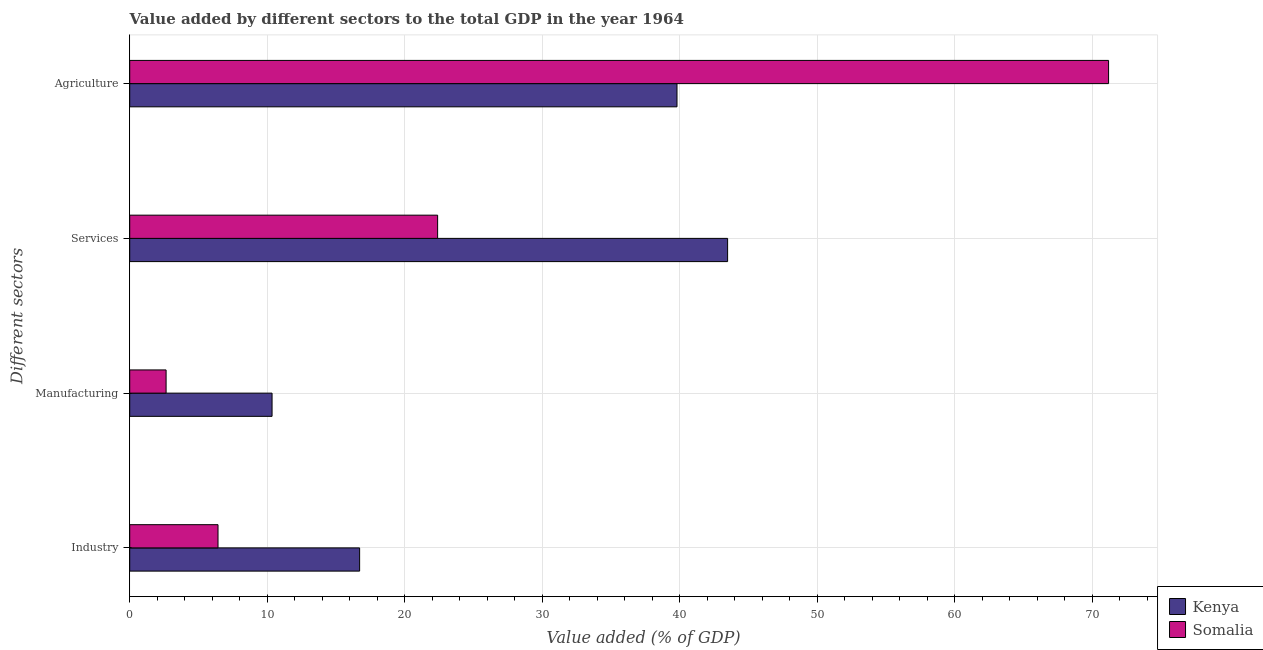How many different coloured bars are there?
Give a very brief answer. 2. How many groups of bars are there?
Keep it short and to the point. 4. Are the number of bars on each tick of the Y-axis equal?
Ensure brevity in your answer.  Yes. How many bars are there on the 1st tick from the top?
Offer a terse response. 2. What is the label of the 2nd group of bars from the top?
Give a very brief answer. Services. What is the value added by manufacturing sector in Kenya?
Make the answer very short. 10.35. Across all countries, what is the maximum value added by manufacturing sector?
Ensure brevity in your answer.  10.35. Across all countries, what is the minimum value added by industrial sector?
Ensure brevity in your answer.  6.42. In which country was the value added by agricultural sector maximum?
Provide a short and direct response. Somalia. In which country was the value added by manufacturing sector minimum?
Offer a terse response. Somalia. What is the total value added by agricultural sector in the graph?
Ensure brevity in your answer.  110.99. What is the difference between the value added by manufacturing sector in Kenya and that in Somalia?
Provide a short and direct response. 7.71. What is the difference between the value added by industrial sector in Somalia and the value added by agricultural sector in Kenya?
Your response must be concise. -33.38. What is the average value added by industrial sector per country?
Give a very brief answer. 11.57. What is the difference between the value added by services sector and value added by industrial sector in Somalia?
Give a very brief answer. 15.97. In how many countries, is the value added by manufacturing sector greater than 36 %?
Your answer should be compact. 0. What is the ratio of the value added by industrial sector in Kenya to that in Somalia?
Offer a terse response. 2.6. Is the difference between the value added by agricultural sector in Kenya and Somalia greater than the difference between the value added by industrial sector in Kenya and Somalia?
Provide a short and direct response. No. What is the difference between the highest and the second highest value added by industrial sector?
Keep it short and to the point. 10.3. What is the difference between the highest and the lowest value added by manufacturing sector?
Your answer should be compact. 7.71. In how many countries, is the value added by services sector greater than the average value added by services sector taken over all countries?
Provide a succinct answer. 1. Is the sum of the value added by industrial sector in Kenya and Somalia greater than the maximum value added by agricultural sector across all countries?
Your answer should be compact. No. Is it the case that in every country, the sum of the value added by manufacturing sector and value added by agricultural sector is greater than the sum of value added by services sector and value added by industrial sector?
Your answer should be compact. Yes. What does the 2nd bar from the top in Manufacturing represents?
Ensure brevity in your answer.  Kenya. What does the 2nd bar from the bottom in Industry represents?
Provide a short and direct response. Somalia. Is it the case that in every country, the sum of the value added by industrial sector and value added by manufacturing sector is greater than the value added by services sector?
Provide a short and direct response. No. Are all the bars in the graph horizontal?
Give a very brief answer. Yes. What is the difference between two consecutive major ticks on the X-axis?
Ensure brevity in your answer.  10. Are the values on the major ticks of X-axis written in scientific E-notation?
Offer a very short reply. No. How are the legend labels stacked?
Ensure brevity in your answer.  Vertical. What is the title of the graph?
Keep it short and to the point. Value added by different sectors to the total GDP in the year 1964. What is the label or title of the X-axis?
Keep it short and to the point. Value added (% of GDP). What is the label or title of the Y-axis?
Give a very brief answer. Different sectors. What is the Value added (% of GDP) of Kenya in Industry?
Ensure brevity in your answer.  16.72. What is the Value added (% of GDP) in Somalia in Industry?
Offer a terse response. 6.42. What is the Value added (% of GDP) of Kenya in Manufacturing?
Your answer should be compact. 10.35. What is the Value added (% of GDP) in Somalia in Manufacturing?
Your response must be concise. 2.65. What is the Value added (% of GDP) of Kenya in Services?
Make the answer very short. 43.48. What is the Value added (% of GDP) of Somalia in Services?
Your answer should be very brief. 22.39. What is the Value added (% of GDP) of Kenya in Agriculture?
Offer a terse response. 39.8. What is the Value added (% of GDP) of Somalia in Agriculture?
Give a very brief answer. 71.19. Across all Different sectors, what is the maximum Value added (% of GDP) of Kenya?
Provide a short and direct response. 43.48. Across all Different sectors, what is the maximum Value added (% of GDP) of Somalia?
Provide a succinct answer. 71.19. Across all Different sectors, what is the minimum Value added (% of GDP) in Kenya?
Keep it short and to the point. 10.35. Across all Different sectors, what is the minimum Value added (% of GDP) of Somalia?
Offer a very short reply. 2.65. What is the total Value added (% of GDP) of Kenya in the graph?
Provide a succinct answer. 110.35. What is the total Value added (% of GDP) in Somalia in the graph?
Your answer should be compact. 102.64. What is the difference between the Value added (% of GDP) in Kenya in Industry and that in Manufacturing?
Provide a short and direct response. 6.37. What is the difference between the Value added (% of GDP) of Somalia in Industry and that in Manufacturing?
Your answer should be compact. 3.78. What is the difference between the Value added (% of GDP) of Kenya in Industry and that in Services?
Offer a very short reply. -26.76. What is the difference between the Value added (% of GDP) in Somalia in Industry and that in Services?
Provide a short and direct response. -15.97. What is the difference between the Value added (% of GDP) of Kenya in Industry and that in Agriculture?
Provide a short and direct response. -23.08. What is the difference between the Value added (% of GDP) of Somalia in Industry and that in Agriculture?
Your answer should be very brief. -64.77. What is the difference between the Value added (% of GDP) of Kenya in Manufacturing and that in Services?
Keep it short and to the point. -33.13. What is the difference between the Value added (% of GDP) of Somalia in Manufacturing and that in Services?
Provide a succinct answer. -19.75. What is the difference between the Value added (% of GDP) in Kenya in Manufacturing and that in Agriculture?
Offer a terse response. -29.45. What is the difference between the Value added (% of GDP) in Somalia in Manufacturing and that in Agriculture?
Ensure brevity in your answer.  -68.54. What is the difference between the Value added (% of GDP) in Kenya in Services and that in Agriculture?
Offer a terse response. 3.68. What is the difference between the Value added (% of GDP) of Somalia in Services and that in Agriculture?
Make the answer very short. -48.8. What is the difference between the Value added (% of GDP) of Kenya in Industry and the Value added (% of GDP) of Somalia in Manufacturing?
Give a very brief answer. 14.07. What is the difference between the Value added (% of GDP) of Kenya in Industry and the Value added (% of GDP) of Somalia in Services?
Provide a succinct answer. -5.67. What is the difference between the Value added (% of GDP) of Kenya in Industry and the Value added (% of GDP) of Somalia in Agriculture?
Offer a terse response. -54.47. What is the difference between the Value added (% of GDP) in Kenya in Manufacturing and the Value added (% of GDP) in Somalia in Services?
Your answer should be very brief. -12.04. What is the difference between the Value added (% of GDP) of Kenya in Manufacturing and the Value added (% of GDP) of Somalia in Agriculture?
Ensure brevity in your answer.  -60.84. What is the difference between the Value added (% of GDP) in Kenya in Services and the Value added (% of GDP) in Somalia in Agriculture?
Provide a succinct answer. -27.71. What is the average Value added (% of GDP) of Kenya per Different sectors?
Make the answer very short. 27.59. What is the average Value added (% of GDP) in Somalia per Different sectors?
Ensure brevity in your answer.  25.66. What is the difference between the Value added (% of GDP) of Kenya and Value added (% of GDP) of Somalia in Industry?
Ensure brevity in your answer.  10.3. What is the difference between the Value added (% of GDP) of Kenya and Value added (% of GDP) of Somalia in Manufacturing?
Provide a short and direct response. 7.71. What is the difference between the Value added (% of GDP) of Kenya and Value added (% of GDP) of Somalia in Services?
Offer a very short reply. 21.09. What is the difference between the Value added (% of GDP) of Kenya and Value added (% of GDP) of Somalia in Agriculture?
Provide a short and direct response. -31.39. What is the ratio of the Value added (% of GDP) of Kenya in Industry to that in Manufacturing?
Your answer should be very brief. 1.62. What is the ratio of the Value added (% of GDP) in Somalia in Industry to that in Manufacturing?
Your answer should be compact. 2.43. What is the ratio of the Value added (% of GDP) of Kenya in Industry to that in Services?
Give a very brief answer. 0.38. What is the ratio of the Value added (% of GDP) in Somalia in Industry to that in Services?
Offer a very short reply. 0.29. What is the ratio of the Value added (% of GDP) in Kenya in Industry to that in Agriculture?
Give a very brief answer. 0.42. What is the ratio of the Value added (% of GDP) of Somalia in Industry to that in Agriculture?
Offer a very short reply. 0.09. What is the ratio of the Value added (% of GDP) of Kenya in Manufacturing to that in Services?
Provide a succinct answer. 0.24. What is the ratio of the Value added (% of GDP) of Somalia in Manufacturing to that in Services?
Provide a short and direct response. 0.12. What is the ratio of the Value added (% of GDP) in Kenya in Manufacturing to that in Agriculture?
Your response must be concise. 0.26. What is the ratio of the Value added (% of GDP) of Somalia in Manufacturing to that in Agriculture?
Your answer should be compact. 0.04. What is the ratio of the Value added (% of GDP) of Kenya in Services to that in Agriculture?
Keep it short and to the point. 1.09. What is the ratio of the Value added (% of GDP) of Somalia in Services to that in Agriculture?
Give a very brief answer. 0.31. What is the difference between the highest and the second highest Value added (% of GDP) in Kenya?
Your answer should be compact. 3.68. What is the difference between the highest and the second highest Value added (% of GDP) of Somalia?
Keep it short and to the point. 48.8. What is the difference between the highest and the lowest Value added (% of GDP) in Kenya?
Make the answer very short. 33.13. What is the difference between the highest and the lowest Value added (% of GDP) of Somalia?
Offer a very short reply. 68.54. 